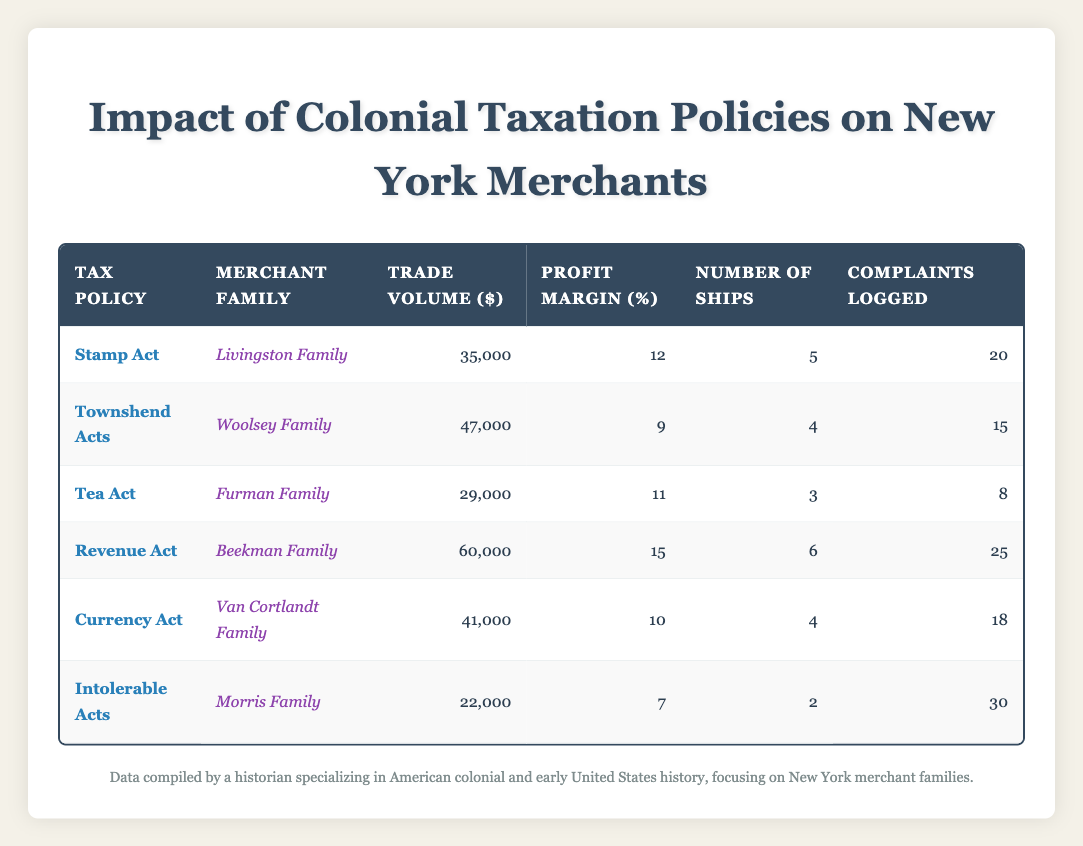What is the trade volume of the Beekman Family? The trade volume is directly listed in the table under the "Trade Volume ($)" column for the Beekman Family, which shows a value of $60,000.
Answer: 60000 Which tax policy had the highest profit margin? By examining the "Profit Margin (%)" column, the Revenue Act shows the highest profit margin at 15%.
Answer: Revenue Act How many ships did the Morris Family have? The number of ships for the Morris Family is listed in the "Number of Ships" column, which states that they had 2 ships.
Answer: 2 What is the average trade volume of the families affected by the Intolerable Acts? The only family affected by the Intolerable Acts is the Morris Family, whose trade volume is $22,000. Since there is only one data point, the average is simply $22,000.
Answer: 22000 Did the Livingstons have more complaints logged than the Furman Family? The Livingston Family logged 20 complaints, while the Furman Family logged 8 complaints, thus yes, the Livingstons had more complaints logged.
Answer: Yes What is the difference in trade volume between the highest and lowest trading families? The highest trade volume is from the Beekman Family at $60,000 and the lowest from the Morris Family at $22,000. The difference is calculated as $60,000 - $22,000 = $38,000.
Answer: 38000 Which tax policy corresponds to the lowest number of ships? The tax policy associated with the lowest number of ships is the Intolerable Acts as indicated by the Morris Family’s entry, which shows they had 2 ships.
Answer: Intolerable Acts What is the total number of complaints logged by all families? To find the total, sum all the complaints logged: 20 + 15 + 8 + 25 + 18 + 30 = 116. Thus, the total complaints logged by all families is 116.
Answer: 116 What was the profit margin of the Van Cortlandt Family, and how does it compare to the average profit margin of all families? The Van Cortlandt Family had a profit margin of 10%. To find the average, sum all profit margins (12 + 9 + 11 + 15 + 10 + 7 = 64) and divide by the number of families (6). The average is 64/6 ≈ 10.67%. The Van Cortlandt Family’s profit margin is less than the average.
Answer: 10% and less than average 